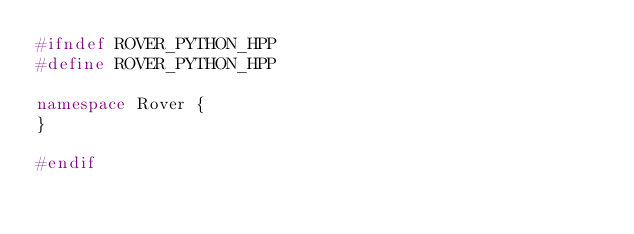<code> <loc_0><loc_0><loc_500><loc_500><_C++_>#ifndef ROVER_PYTHON_HPP
#define ROVER_PYTHON_HPP

namespace Rover {
}

#endif
</code> 